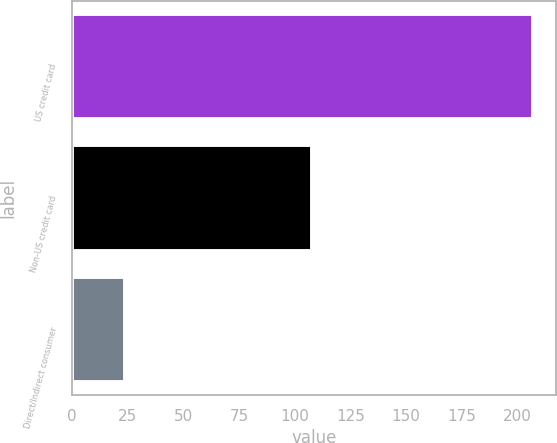Convert chart to OTSL. <chart><loc_0><loc_0><loc_500><loc_500><bar_chart><fcel>US credit card<fcel>Non-US credit card<fcel>Direct/Indirect consumer<nl><fcel>207<fcel>108<fcel>24<nl></chart> 